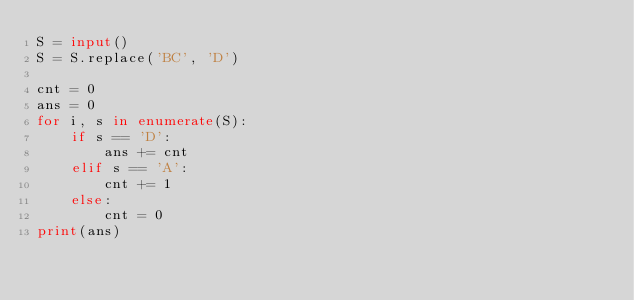Convert code to text. <code><loc_0><loc_0><loc_500><loc_500><_Python_>S = input()
S = S.replace('BC', 'D')

cnt = 0
ans = 0
for i, s in enumerate(S):
    if s == 'D':
        ans += cnt
    elif s == 'A':
        cnt += 1
    else:
        cnt = 0
print(ans)
</code> 